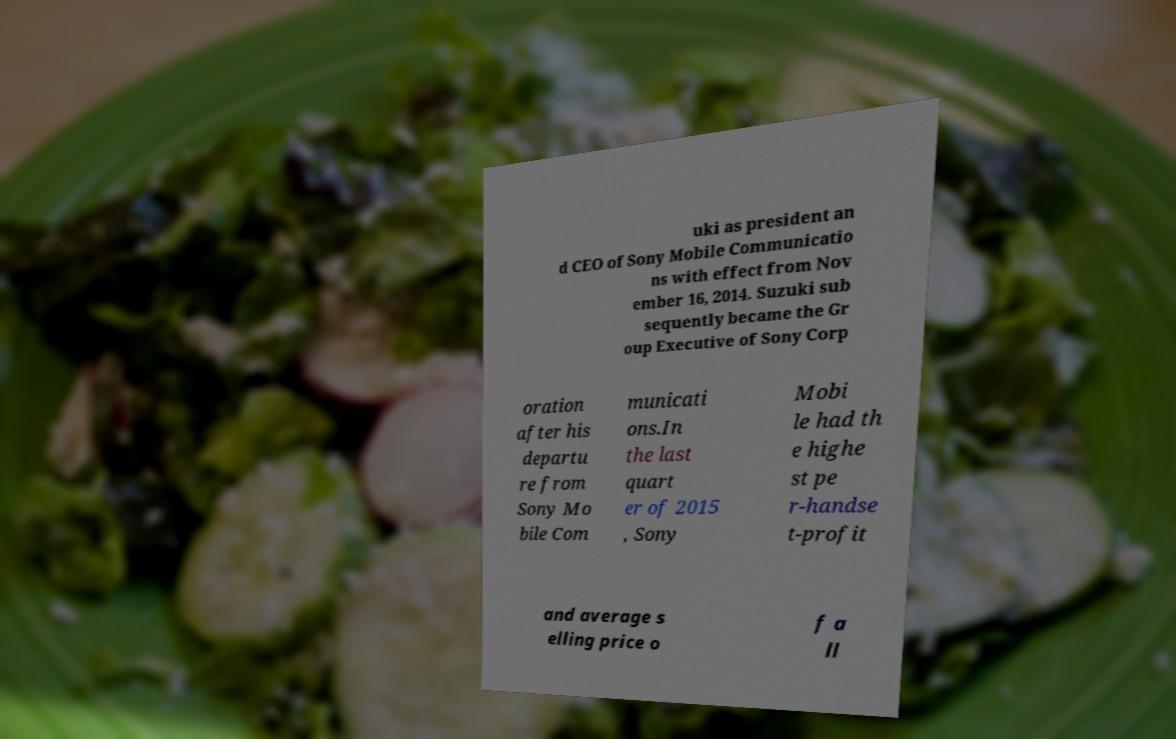There's text embedded in this image that I need extracted. Can you transcribe it verbatim? uki as president an d CEO of Sony Mobile Communicatio ns with effect from Nov ember 16, 2014. Suzuki sub sequently became the Gr oup Executive of Sony Corp oration after his departu re from Sony Mo bile Com municati ons.In the last quart er of 2015 , Sony Mobi le had th e highe st pe r-handse t-profit and average s elling price o f a ll 